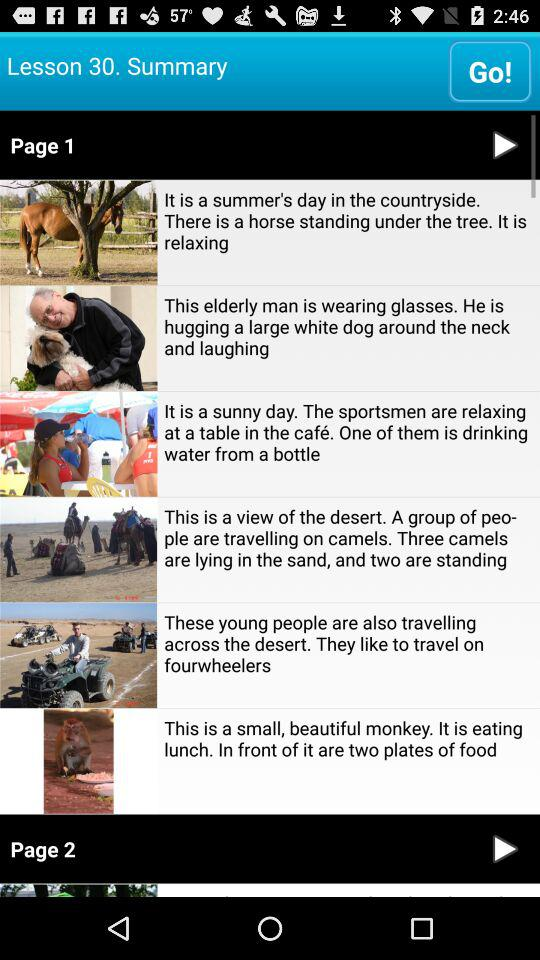What is the lesson number? The lesson number is 30. 